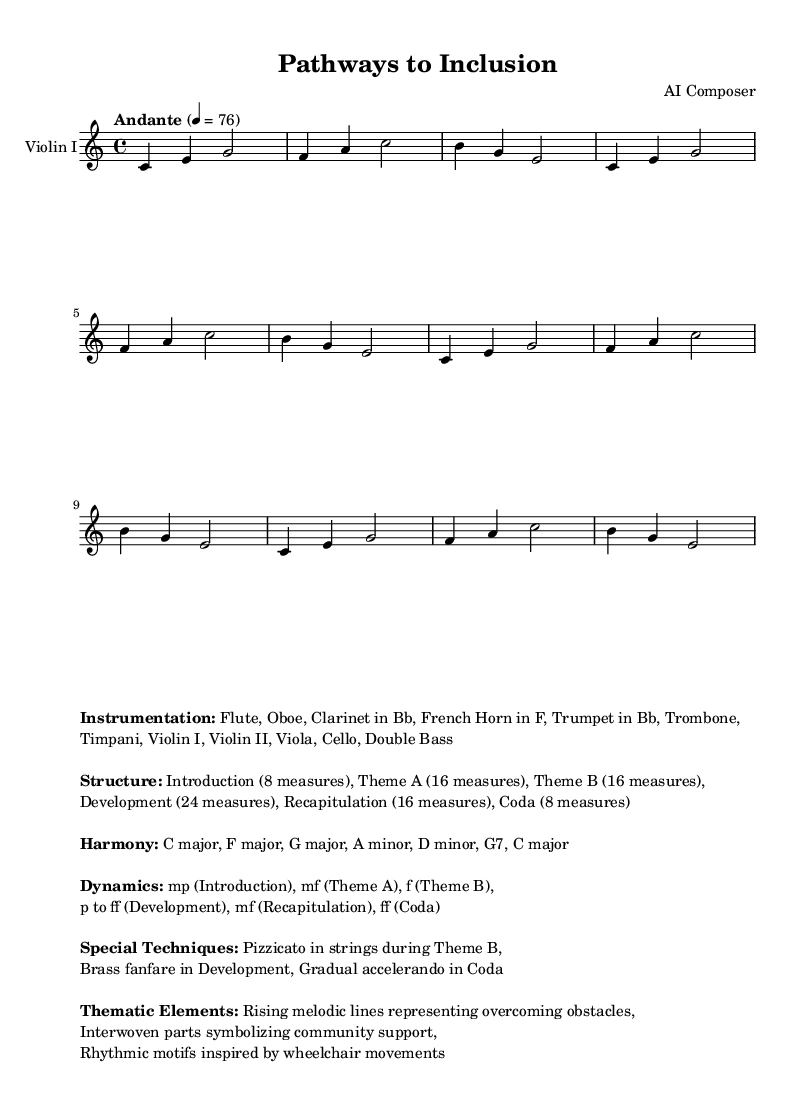What is the time signature of this music? The time signature is indicated at the beginning of the score, where it shows a 4 over 4, meaning there are four beats in a measure and the quarter note gets one beat.
Answer: 4/4 What is the tempo marking of this piece? The tempo is specified as "Andante" with a metronome marking of 76 beats per minute, which indicates a moderately slow pace.
Answer: Andante, 76 How many measures are in the theme A? Looking at the structure outlined in the markup, theme A consists of 16 measures as explicitly stated.
Answer: 16 measures What is the dynamic marking for the development section? The dynamics during the development indicate a range from piano (p) to fortissimo (ff), suggesting a rise in intensity throughout this section.
Answer: p to ff What special technique is used in Theme B? The markup lists pizzicato in strings as a special technique in Theme B, where the players pluck the strings instead of using the bow.
Answer: Pizzicato What thematic element represents community support? The markup identifies that interwoven parts symbolize community support, indicating a collaborative musical texture among the instrument sections.
Answer: Interwoven parts What key is the symphony primarily composed in? The key is specified at the beginning of the score as C major, which has no sharps or flats and establishes the harmonic center of the piece.
Answer: C major 